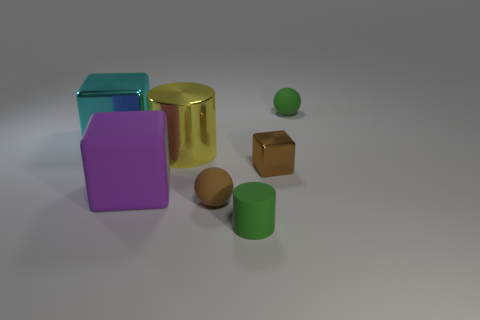Do the tiny brown shiny object and the big purple object have the same shape?
Your response must be concise. Yes. There is a tiny green rubber thing in front of the large rubber object; are there any tiny rubber objects that are behind it?
Ensure brevity in your answer.  Yes. Are there the same number of big rubber cubes that are behind the yellow cylinder and brown metal cylinders?
Keep it short and to the point. Yes. How many other things are there of the same size as the yellow object?
Your answer should be very brief. 2. Is the material of the small green thing that is in front of the yellow cylinder the same as the small ball behind the large yellow cylinder?
Make the answer very short. Yes. There is a green object that is on the left side of the tiny green sphere that is right of the big purple cube; how big is it?
Your response must be concise. Small. Are there any matte cylinders that have the same color as the large metal cylinder?
Ensure brevity in your answer.  No. Does the matte sphere that is in front of the large matte thing have the same color as the block that is right of the yellow object?
Offer a terse response. Yes. What is the shape of the yellow shiny thing?
Your response must be concise. Cylinder. There is a large cyan thing; how many large cyan metallic blocks are to the left of it?
Provide a succinct answer. 0. 